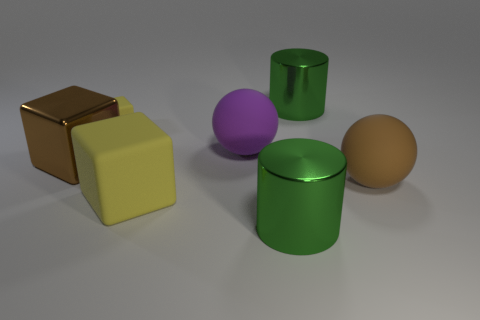Add 1 large purple rubber spheres. How many objects exist? 8 Subtract all small cubes. How many cubes are left? 2 Subtract 2 cylinders. How many cylinders are left? 0 Subtract all cubes. How many objects are left? 4 Subtract all brown cubes. How many cubes are left? 2 Subtract all yellow cubes. Subtract all cyan cylinders. How many cubes are left? 1 Subtract all gray blocks. How many red balls are left? 0 Subtract all large matte balls. Subtract all brown shiny spheres. How many objects are left? 5 Add 3 small yellow blocks. How many small yellow blocks are left? 4 Add 3 large brown matte things. How many large brown matte things exist? 4 